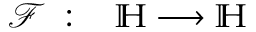Convert formula to latex. <formula><loc_0><loc_0><loc_500><loc_500>\begin{array} { r l } { \mathcal { F } \, \colon \, } & \mathbb { H } \longrightarrow \mathbb { H } } \end{array}</formula> 